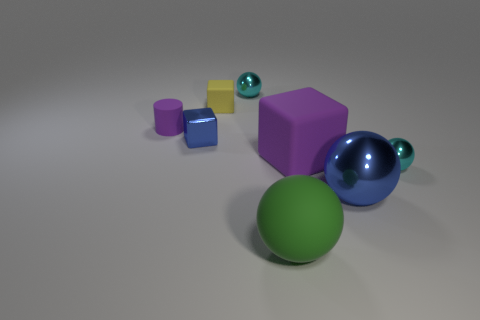Do the sphere that is in front of the big blue metallic object and the rubber cylinder have the same color?
Make the answer very short. No. The purple object that is the same size as the yellow object is what shape?
Ensure brevity in your answer.  Cylinder. What number of other things are the same color as the metal block?
Ensure brevity in your answer.  1. How many other objects are there of the same material as the tiny purple cylinder?
Ensure brevity in your answer.  3. There is a green thing; is it the same size as the cyan shiny ball that is behind the yellow matte cube?
Offer a very short reply. No. What is the color of the rubber ball?
Offer a terse response. Green. What is the shape of the blue shiny thing that is behind the small shiny sphere to the right of the purple object in front of the purple rubber cylinder?
Keep it short and to the point. Cube. What is the material of the small cyan thing left of the tiny cyan ball that is in front of the large purple rubber thing?
Your answer should be very brief. Metal. There is a tiny yellow object that is made of the same material as the small cylinder; what is its shape?
Provide a succinct answer. Cube. Is there any other thing that is the same shape as the small purple thing?
Provide a short and direct response. No. 